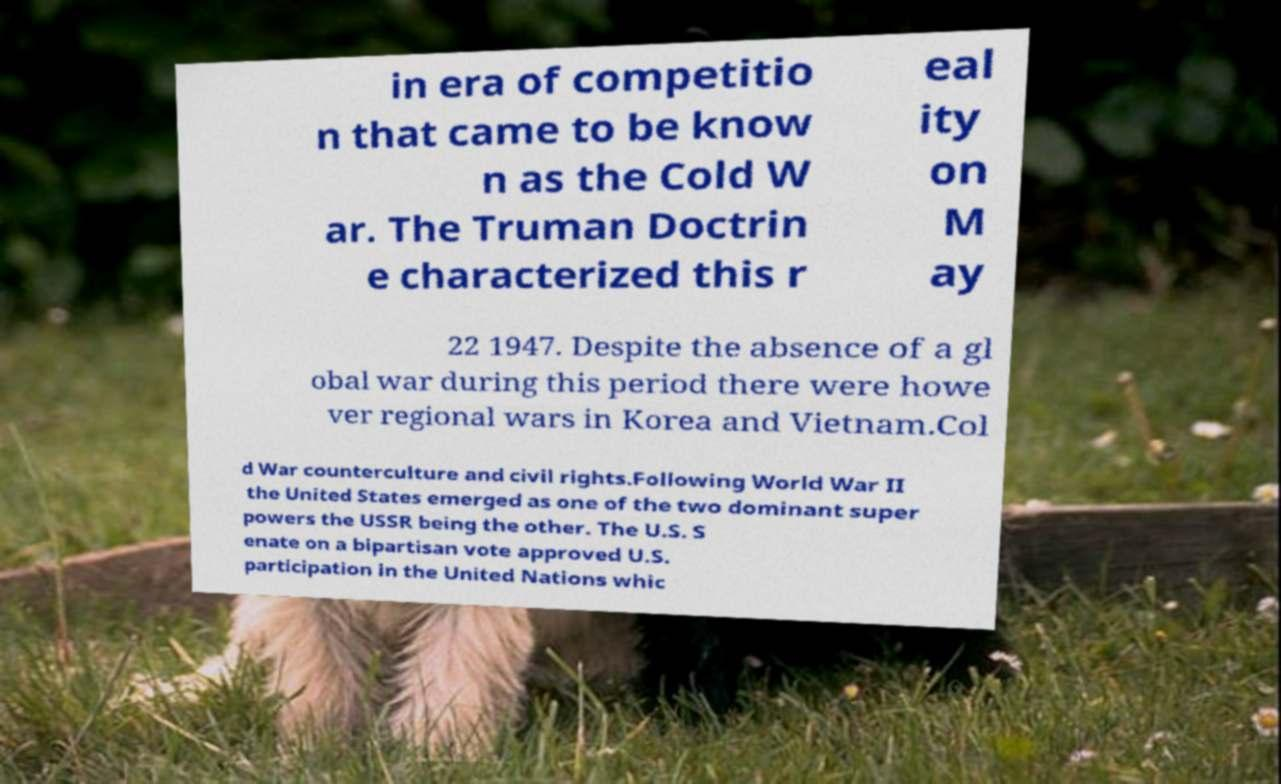Can you read and provide the text displayed in the image?This photo seems to have some interesting text. Can you extract and type it out for me? in era of competitio n that came to be know n as the Cold W ar. The Truman Doctrin e characterized this r eal ity on M ay 22 1947. Despite the absence of a gl obal war during this period there were howe ver regional wars in Korea and Vietnam.Col d War counterculture and civil rights.Following World War II the United States emerged as one of the two dominant super powers the USSR being the other. The U.S. S enate on a bipartisan vote approved U.S. participation in the United Nations whic 